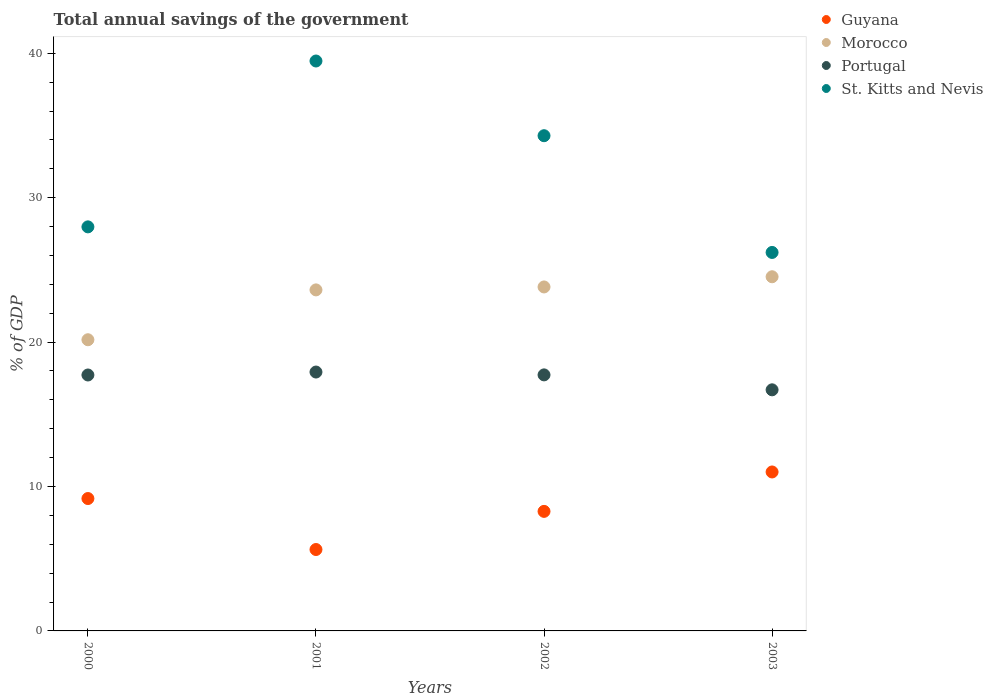How many different coloured dotlines are there?
Give a very brief answer. 4. What is the total annual savings of the government in Guyana in 2001?
Give a very brief answer. 5.64. Across all years, what is the maximum total annual savings of the government in St. Kitts and Nevis?
Offer a terse response. 39.47. Across all years, what is the minimum total annual savings of the government in St. Kitts and Nevis?
Your answer should be compact. 26.21. What is the total total annual savings of the government in Guyana in the graph?
Give a very brief answer. 34.09. What is the difference between the total annual savings of the government in Guyana in 2002 and that in 2003?
Provide a succinct answer. -2.73. What is the difference between the total annual savings of the government in St. Kitts and Nevis in 2002 and the total annual savings of the government in Guyana in 2003?
Offer a terse response. 23.29. What is the average total annual savings of the government in Portugal per year?
Your response must be concise. 17.52. In the year 2003, what is the difference between the total annual savings of the government in Guyana and total annual savings of the government in St. Kitts and Nevis?
Keep it short and to the point. -15.2. What is the ratio of the total annual savings of the government in Morocco in 2001 to that in 2002?
Your response must be concise. 0.99. Is the total annual savings of the government in St. Kitts and Nevis in 2000 less than that in 2001?
Your answer should be compact. Yes. Is the difference between the total annual savings of the government in Guyana in 2002 and 2003 greater than the difference between the total annual savings of the government in St. Kitts and Nevis in 2002 and 2003?
Give a very brief answer. No. What is the difference between the highest and the second highest total annual savings of the government in Morocco?
Keep it short and to the point. 0.71. What is the difference between the highest and the lowest total annual savings of the government in Morocco?
Offer a very short reply. 4.36. In how many years, is the total annual savings of the government in Guyana greater than the average total annual savings of the government in Guyana taken over all years?
Your response must be concise. 2. Is it the case that in every year, the sum of the total annual savings of the government in Morocco and total annual savings of the government in Portugal  is greater than the sum of total annual savings of the government in St. Kitts and Nevis and total annual savings of the government in Guyana?
Provide a short and direct response. No. Does the total annual savings of the government in St. Kitts and Nevis monotonically increase over the years?
Offer a terse response. No. Is the total annual savings of the government in Morocco strictly greater than the total annual savings of the government in St. Kitts and Nevis over the years?
Provide a succinct answer. No. Is the total annual savings of the government in Morocco strictly less than the total annual savings of the government in Guyana over the years?
Offer a very short reply. No. How many dotlines are there?
Ensure brevity in your answer.  4. How many years are there in the graph?
Make the answer very short. 4. Does the graph contain any zero values?
Your response must be concise. No. Does the graph contain grids?
Your response must be concise. No. Where does the legend appear in the graph?
Your response must be concise. Top right. How many legend labels are there?
Make the answer very short. 4. What is the title of the graph?
Provide a short and direct response. Total annual savings of the government. What is the label or title of the Y-axis?
Ensure brevity in your answer.  % of GDP. What is the % of GDP of Guyana in 2000?
Your answer should be very brief. 9.17. What is the % of GDP of Morocco in 2000?
Ensure brevity in your answer.  20.16. What is the % of GDP of Portugal in 2000?
Offer a very short reply. 17.72. What is the % of GDP of St. Kitts and Nevis in 2000?
Make the answer very short. 27.98. What is the % of GDP in Guyana in 2001?
Give a very brief answer. 5.64. What is the % of GDP of Morocco in 2001?
Keep it short and to the point. 23.62. What is the % of GDP in Portugal in 2001?
Your answer should be compact. 17.93. What is the % of GDP of St. Kitts and Nevis in 2001?
Provide a succinct answer. 39.47. What is the % of GDP of Guyana in 2002?
Your response must be concise. 8.28. What is the % of GDP in Morocco in 2002?
Your answer should be very brief. 23.82. What is the % of GDP of Portugal in 2002?
Keep it short and to the point. 17.73. What is the % of GDP of St. Kitts and Nevis in 2002?
Offer a terse response. 34.29. What is the % of GDP of Guyana in 2003?
Your answer should be very brief. 11.01. What is the % of GDP in Morocco in 2003?
Ensure brevity in your answer.  24.52. What is the % of GDP of Portugal in 2003?
Offer a terse response. 16.7. What is the % of GDP of St. Kitts and Nevis in 2003?
Offer a very short reply. 26.21. Across all years, what is the maximum % of GDP of Guyana?
Provide a succinct answer. 11.01. Across all years, what is the maximum % of GDP in Morocco?
Offer a terse response. 24.52. Across all years, what is the maximum % of GDP in Portugal?
Give a very brief answer. 17.93. Across all years, what is the maximum % of GDP of St. Kitts and Nevis?
Offer a terse response. 39.47. Across all years, what is the minimum % of GDP of Guyana?
Provide a short and direct response. 5.64. Across all years, what is the minimum % of GDP in Morocco?
Your response must be concise. 20.16. Across all years, what is the minimum % of GDP of Portugal?
Ensure brevity in your answer.  16.7. Across all years, what is the minimum % of GDP in St. Kitts and Nevis?
Your response must be concise. 26.21. What is the total % of GDP of Guyana in the graph?
Your answer should be compact. 34.09. What is the total % of GDP in Morocco in the graph?
Provide a short and direct response. 92.12. What is the total % of GDP of Portugal in the graph?
Your answer should be very brief. 70.07. What is the total % of GDP of St. Kitts and Nevis in the graph?
Provide a short and direct response. 127.95. What is the difference between the % of GDP of Guyana in 2000 and that in 2001?
Your answer should be very brief. 3.53. What is the difference between the % of GDP of Morocco in 2000 and that in 2001?
Provide a short and direct response. -3.45. What is the difference between the % of GDP in Portugal in 2000 and that in 2001?
Your response must be concise. -0.2. What is the difference between the % of GDP in St. Kitts and Nevis in 2000 and that in 2001?
Provide a succinct answer. -11.49. What is the difference between the % of GDP in Guyana in 2000 and that in 2002?
Ensure brevity in your answer.  0.89. What is the difference between the % of GDP in Morocco in 2000 and that in 2002?
Provide a short and direct response. -3.66. What is the difference between the % of GDP of Portugal in 2000 and that in 2002?
Your response must be concise. -0.01. What is the difference between the % of GDP in St. Kitts and Nevis in 2000 and that in 2002?
Your answer should be very brief. -6.31. What is the difference between the % of GDP in Guyana in 2000 and that in 2003?
Provide a short and direct response. -1.84. What is the difference between the % of GDP in Morocco in 2000 and that in 2003?
Provide a succinct answer. -4.36. What is the difference between the % of GDP of Portugal in 2000 and that in 2003?
Offer a very short reply. 1.03. What is the difference between the % of GDP of St. Kitts and Nevis in 2000 and that in 2003?
Your answer should be compact. 1.77. What is the difference between the % of GDP of Guyana in 2001 and that in 2002?
Provide a short and direct response. -2.64. What is the difference between the % of GDP in Morocco in 2001 and that in 2002?
Give a very brief answer. -0.2. What is the difference between the % of GDP in Portugal in 2001 and that in 2002?
Offer a very short reply. 0.2. What is the difference between the % of GDP of St. Kitts and Nevis in 2001 and that in 2002?
Make the answer very short. 5.17. What is the difference between the % of GDP in Guyana in 2001 and that in 2003?
Ensure brevity in your answer.  -5.37. What is the difference between the % of GDP of Morocco in 2001 and that in 2003?
Offer a very short reply. -0.91. What is the difference between the % of GDP in Portugal in 2001 and that in 2003?
Give a very brief answer. 1.23. What is the difference between the % of GDP of St. Kitts and Nevis in 2001 and that in 2003?
Your answer should be very brief. 13.26. What is the difference between the % of GDP in Guyana in 2002 and that in 2003?
Ensure brevity in your answer.  -2.73. What is the difference between the % of GDP in Morocco in 2002 and that in 2003?
Ensure brevity in your answer.  -0.71. What is the difference between the % of GDP in Portugal in 2002 and that in 2003?
Keep it short and to the point. 1.03. What is the difference between the % of GDP in St. Kitts and Nevis in 2002 and that in 2003?
Ensure brevity in your answer.  8.08. What is the difference between the % of GDP of Guyana in 2000 and the % of GDP of Morocco in 2001?
Provide a short and direct response. -14.45. What is the difference between the % of GDP in Guyana in 2000 and the % of GDP in Portugal in 2001?
Give a very brief answer. -8.76. What is the difference between the % of GDP of Guyana in 2000 and the % of GDP of St. Kitts and Nevis in 2001?
Your answer should be compact. -30.3. What is the difference between the % of GDP in Morocco in 2000 and the % of GDP in Portugal in 2001?
Your answer should be compact. 2.24. What is the difference between the % of GDP of Morocco in 2000 and the % of GDP of St. Kitts and Nevis in 2001?
Your answer should be compact. -19.3. What is the difference between the % of GDP in Portugal in 2000 and the % of GDP in St. Kitts and Nevis in 2001?
Offer a terse response. -21.74. What is the difference between the % of GDP in Guyana in 2000 and the % of GDP in Morocco in 2002?
Give a very brief answer. -14.65. What is the difference between the % of GDP of Guyana in 2000 and the % of GDP of Portugal in 2002?
Keep it short and to the point. -8.56. What is the difference between the % of GDP in Guyana in 2000 and the % of GDP in St. Kitts and Nevis in 2002?
Provide a succinct answer. -25.12. What is the difference between the % of GDP in Morocco in 2000 and the % of GDP in Portugal in 2002?
Your answer should be compact. 2.43. What is the difference between the % of GDP of Morocco in 2000 and the % of GDP of St. Kitts and Nevis in 2002?
Ensure brevity in your answer.  -14.13. What is the difference between the % of GDP in Portugal in 2000 and the % of GDP in St. Kitts and Nevis in 2002?
Give a very brief answer. -16.57. What is the difference between the % of GDP of Guyana in 2000 and the % of GDP of Morocco in 2003?
Give a very brief answer. -15.36. What is the difference between the % of GDP in Guyana in 2000 and the % of GDP in Portugal in 2003?
Offer a terse response. -7.53. What is the difference between the % of GDP in Guyana in 2000 and the % of GDP in St. Kitts and Nevis in 2003?
Ensure brevity in your answer.  -17.04. What is the difference between the % of GDP of Morocco in 2000 and the % of GDP of Portugal in 2003?
Make the answer very short. 3.47. What is the difference between the % of GDP in Morocco in 2000 and the % of GDP in St. Kitts and Nevis in 2003?
Your answer should be very brief. -6.04. What is the difference between the % of GDP in Portugal in 2000 and the % of GDP in St. Kitts and Nevis in 2003?
Provide a short and direct response. -8.49. What is the difference between the % of GDP in Guyana in 2001 and the % of GDP in Morocco in 2002?
Provide a succinct answer. -18.18. What is the difference between the % of GDP of Guyana in 2001 and the % of GDP of Portugal in 2002?
Your answer should be compact. -12.09. What is the difference between the % of GDP in Guyana in 2001 and the % of GDP in St. Kitts and Nevis in 2002?
Make the answer very short. -28.66. What is the difference between the % of GDP in Morocco in 2001 and the % of GDP in Portugal in 2002?
Your answer should be compact. 5.89. What is the difference between the % of GDP of Morocco in 2001 and the % of GDP of St. Kitts and Nevis in 2002?
Your answer should be very brief. -10.68. What is the difference between the % of GDP of Portugal in 2001 and the % of GDP of St. Kitts and Nevis in 2002?
Offer a terse response. -16.37. What is the difference between the % of GDP in Guyana in 2001 and the % of GDP in Morocco in 2003?
Ensure brevity in your answer.  -18.89. What is the difference between the % of GDP in Guyana in 2001 and the % of GDP in Portugal in 2003?
Your response must be concise. -11.06. What is the difference between the % of GDP in Guyana in 2001 and the % of GDP in St. Kitts and Nevis in 2003?
Offer a very short reply. -20.57. What is the difference between the % of GDP in Morocco in 2001 and the % of GDP in Portugal in 2003?
Your response must be concise. 6.92. What is the difference between the % of GDP of Morocco in 2001 and the % of GDP of St. Kitts and Nevis in 2003?
Give a very brief answer. -2.59. What is the difference between the % of GDP of Portugal in 2001 and the % of GDP of St. Kitts and Nevis in 2003?
Offer a very short reply. -8.28. What is the difference between the % of GDP in Guyana in 2002 and the % of GDP in Morocco in 2003?
Offer a terse response. -16.25. What is the difference between the % of GDP in Guyana in 2002 and the % of GDP in Portugal in 2003?
Ensure brevity in your answer.  -8.42. What is the difference between the % of GDP of Guyana in 2002 and the % of GDP of St. Kitts and Nevis in 2003?
Offer a terse response. -17.93. What is the difference between the % of GDP in Morocco in 2002 and the % of GDP in Portugal in 2003?
Make the answer very short. 7.12. What is the difference between the % of GDP in Morocco in 2002 and the % of GDP in St. Kitts and Nevis in 2003?
Ensure brevity in your answer.  -2.39. What is the difference between the % of GDP of Portugal in 2002 and the % of GDP of St. Kitts and Nevis in 2003?
Ensure brevity in your answer.  -8.48. What is the average % of GDP of Guyana per year?
Your answer should be very brief. 8.52. What is the average % of GDP in Morocco per year?
Offer a very short reply. 23.03. What is the average % of GDP in Portugal per year?
Offer a very short reply. 17.52. What is the average % of GDP in St. Kitts and Nevis per year?
Offer a very short reply. 31.99. In the year 2000, what is the difference between the % of GDP of Guyana and % of GDP of Morocco?
Provide a succinct answer. -11. In the year 2000, what is the difference between the % of GDP in Guyana and % of GDP in Portugal?
Offer a terse response. -8.56. In the year 2000, what is the difference between the % of GDP in Guyana and % of GDP in St. Kitts and Nevis?
Keep it short and to the point. -18.81. In the year 2000, what is the difference between the % of GDP in Morocco and % of GDP in Portugal?
Keep it short and to the point. 2.44. In the year 2000, what is the difference between the % of GDP of Morocco and % of GDP of St. Kitts and Nevis?
Keep it short and to the point. -7.82. In the year 2000, what is the difference between the % of GDP in Portugal and % of GDP in St. Kitts and Nevis?
Make the answer very short. -10.26. In the year 2001, what is the difference between the % of GDP of Guyana and % of GDP of Morocco?
Offer a very short reply. -17.98. In the year 2001, what is the difference between the % of GDP in Guyana and % of GDP in Portugal?
Provide a succinct answer. -12.29. In the year 2001, what is the difference between the % of GDP in Guyana and % of GDP in St. Kitts and Nevis?
Provide a short and direct response. -33.83. In the year 2001, what is the difference between the % of GDP of Morocco and % of GDP of Portugal?
Ensure brevity in your answer.  5.69. In the year 2001, what is the difference between the % of GDP of Morocco and % of GDP of St. Kitts and Nevis?
Your response must be concise. -15.85. In the year 2001, what is the difference between the % of GDP in Portugal and % of GDP in St. Kitts and Nevis?
Give a very brief answer. -21.54. In the year 2002, what is the difference between the % of GDP of Guyana and % of GDP of Morocco?
Your response must be concise. -15.54. In the year 2002, what is the difference between the % of GDP in Guyana and % of GDP in Portugal?
Ensure brevity in your answer.  -9.45. In the year 2002, what is the difference between the % of GDP of Guyana and % of GDP of St. Kitts and Nevis?
Make the answer very short. -26.01. In the year 2002, what is the difference between the % of GDP in Morocco and % of GDP in Portugal?
Your answer should be very brief. 6.09. In the year 2002, what is the difference between the % of GDP in Morocco and % of GDP in St. Kitts and Nevis?
Offer a very short reply. -10.47. In the year 2002, what is the difference between the % of GDP in Portugal and % of GDP in St. Kitts and Nevis?
Offer a terse response. -16.56. In the year 2003, what is the difference between the % of GDP in Guyana and % of GDP in Morocco?
Give a very brief answer. -13.52. In the year 2003, what is the difference between the % of GDP in Guyana and % of GDP in Portugal?
Your answer should be very brief. -5.69. In the year 2003, what is the difference between the % of GDP of Guyana and % of GDP of St. Kitts and Nevis?
Your answer should be compact. -15.2. In the year 2003, what is the difference between the % of GDP of Morocco and % of GDP of Portugal?
Make the answer very short. 7.83. In the year 2003, what is the difference between the % of GDP of Morocco and % of GDP of St. Kitts and Nevis?
Your answer should be compact. -1.68. In the year 2003, what is the difference between the % of GDP in Portugal and % of GDP in St. Kitts and Nevis?
Make the answer very short. -9.51. What is the ratio of the % of GDP in Guyana in 2000 to that in 2001?
Give a very brief answer. 1.63. What is the ratio of the % of GDP of Morocco in 2000 to that in 2001?
Offer a very short reply. 0.85. What is the ratio of the % of GDP of Portugal in 2000 to that in 2001?
Your answer should be compact. 0.99. What is the ratio of the % of GDP in St. Kitts and Nevis in 2000 to that in 2001?
Offer a terse response. 0.71. What is the ratio of the % of GDP in Guyana in 2000 to that in 2002?
Your answer should be very brief. 1.11. What is the ratio of the % of GDP of Morocco in 2000 to that in 2002?
Provide a succinct answer. 0.85. What is the ratio of the % of GDP of St. Kitts and Nevis in 2000 to that in 2002?
Your answer should be very brief. 0.82. What is the ratio of the % of GDP of Guyana in 2000 to that in 2003?
Your answer should be very brief. 0.83. What is the ratio of the % of GDP in Morocco in 2000 to that in 2003?
Give a very brief answer. 0.82. What is the ratio of the % of GDP of Portugal in 2000 to that in 2003?
Your response must be concise. 1.06. What is the ratio of the % of GDP in St. Kitts and Nevis in 2000 to that in 2003?
Your response must be concise. 1.07. What is the ratio of the % of GDP in Guyana in 2001 to that in 2002?
Make the answer very short. 0.68. What is the ratio of the % of GDP in Morocco in 2001 to that in 2002?
Offer a terse response. 0.99. What is the ratio of the % of GDP in Portugal in 2001 to that in 2002?
Offer a very short reply. 1.01. What is the ratio of the % of GDP of St. Kitts and Nevis in 2001 to that in 2002?
Your answer should be very brief. 1.15. What is the ratio of the % of GDP in Guyana in 2001 to that in 2003?
Keep it short and to the point. 0.51. What is the ratio of the % of GDP of Morocco in 2001 to that in 2003?
Provide a succinct answer. 0.96. What is the ratio of the % of GDP of Portugal in 2001 to that in 2003?
Your answer should be compact. 1.07. What is the ratio of the % of GDP in St. Kitts and Nevis in 2001 to that in 2003?
Provide a succinct answer. 1.51. What is the ratio of the % of GDP of Guyana in 2002 to that in 2003?
Make the answer very short. 0.75. What is the ratio of the % of GDP of Morocco in 2002 to that in 2003?
Provide a short and direct response. 0.97. What is the ratio of the % of GDP in Portugal in 2002 to that in 2003?
Give a very brief answer. 1.06. What is the ratio of the % of GDP in St. Kitts and Nevis in 2002 to that in 2003?
Ensure brevity in your answer.  1.31. What is the difference between the highest and the second highest % of GDP of Guyana?
Your answer should be very brief. 1.84. What is the difference between the highest and the second highest % of GDP of Morocco?
Give a very brief answer. 0.71. What is the difference between the highest and the second highest % of GDP of Portugal?
Keep it short and to the point. 0.2. What is the difference between the highest and the second highest % of GDP of St. Kitts and Nevis?
Give a very brief answer. 5.17. What is the difference between the highest and the lowest % of GDP in Guyana?
Keep it short and to the point. 5.37. What is the difference between the highest and the lowest % of GDP in Morocco?
Provide a succinct answer. 4.36. What is the difference between the highest and the lowest % of GDP in Portugal?
Offer a terse response. 1.23. What is the difference between the highest and the lowest % of GDP in St. Kitts and Nevis?
Make the answer very short. 13.26. 